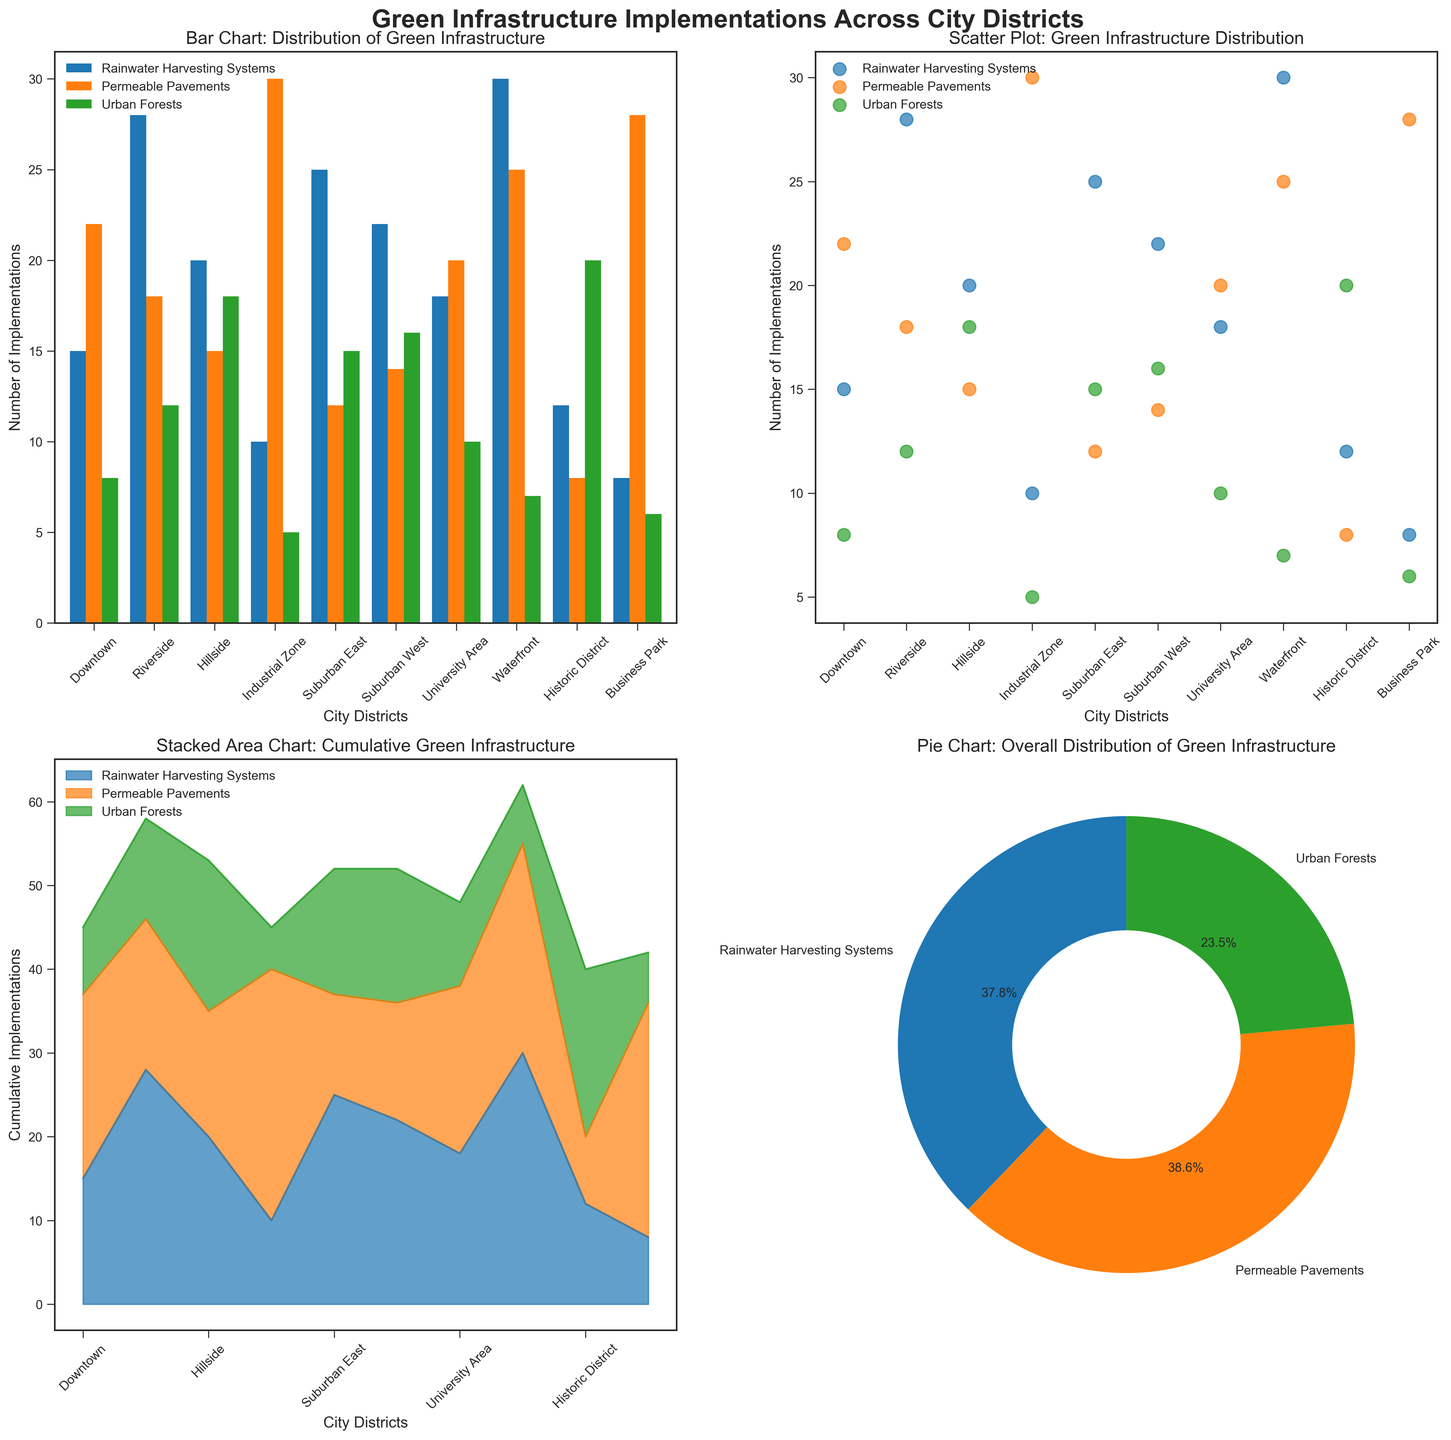What is the title of the bar chart in the figure? Look at the top of the bar chart subplot to find the title. The title usually describes what the chart is about.
Answer: Bar Chart: Distribution of Green Infrastructure Based on the scatter plot, which city district has implemented the most rainwater harvesting systems? Check the scatter plot subplot and identify the district with the highest corresponding point on the Rainwater Harvesting Systems axis.
Answer: Waterfront How many city districts have implemented more than 15 urban forests according to the area chart? Observe the area chart and determine the number of districts where the value for Urban Forests exceeds 15.
Answer: Four What percentage of total implementations is attributed to permeable pavements as shown in the pie chart? Look at the pie chart subplot and find the segment corresponding to permeable pavements. The percentage will be labeled.
Answer: 36.4% Which city district has the fewest rainwater harvesting systems and how many does it have according to the bar chart? Look at the bars representing rainwater harvesting systems in each district and identify the smallest one.
Answer: Business Park with 8 In the scatter plot, which type of green infrastructure shows the least variability across districts? Compare the spread of points for each type of infrastructure in the scatter plot and determine which has the smallest range of values.
Answer: Urban Forests What is the average number of permeable pavements implemented across all city districts as shown in the bar chart? Sum the values for permeable pavements from all districts in the bar chart and divide by the number of districts.
Answer: 19.2 Which city district shows the highest number of cumulative green infrastructure implementations in the stacked area chart? Identify the district with the tallest combined stack in the area chart.
Answer: Waterfront Based on the pie chart, which type of green infrastructure has the smallest share of the total implementations? Find the segment of the pie chart that is the smallest in size.
Answer: Urban Forests In the scatter plot, which district shows a higher number of urban forests than rainwater harvesting systems? Compare the points for Urban Forests and Rainwater Harvesting Systems in each district in the scatter plot.
Answer: Historic District 